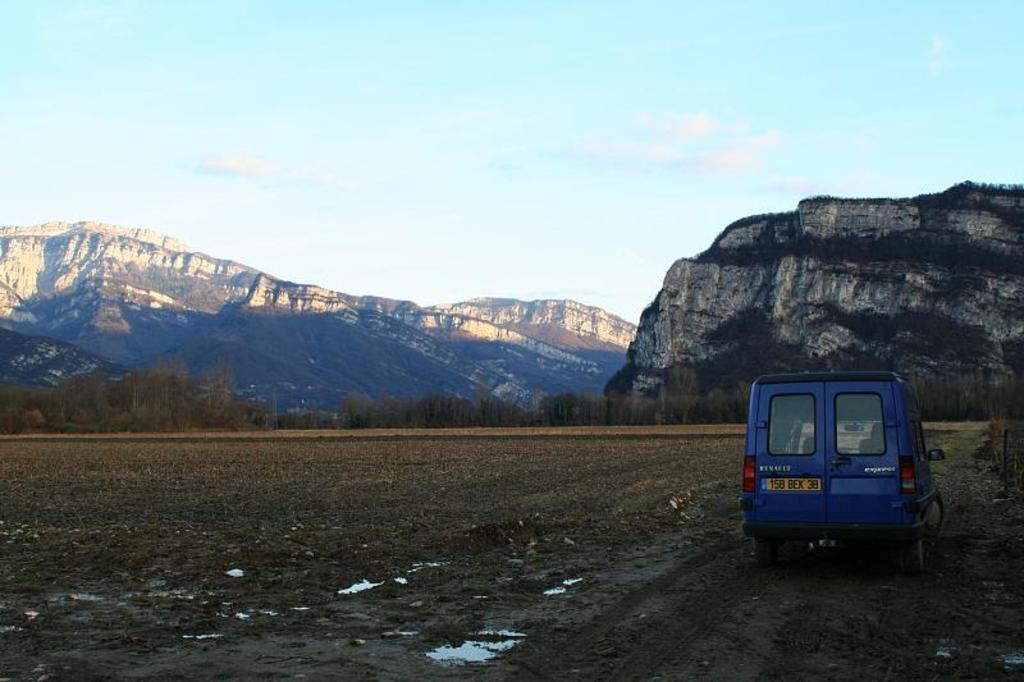What color is the vehicle in the image? The vehicle in the image is blue. Where is the vehicle located in the image? The vehicle is on a sand road. What can be seen in the background of the image? There are trees and buildings in the background of the image. How many birds are sitting on the watch in the image? There are no birds or watches present in the image. 